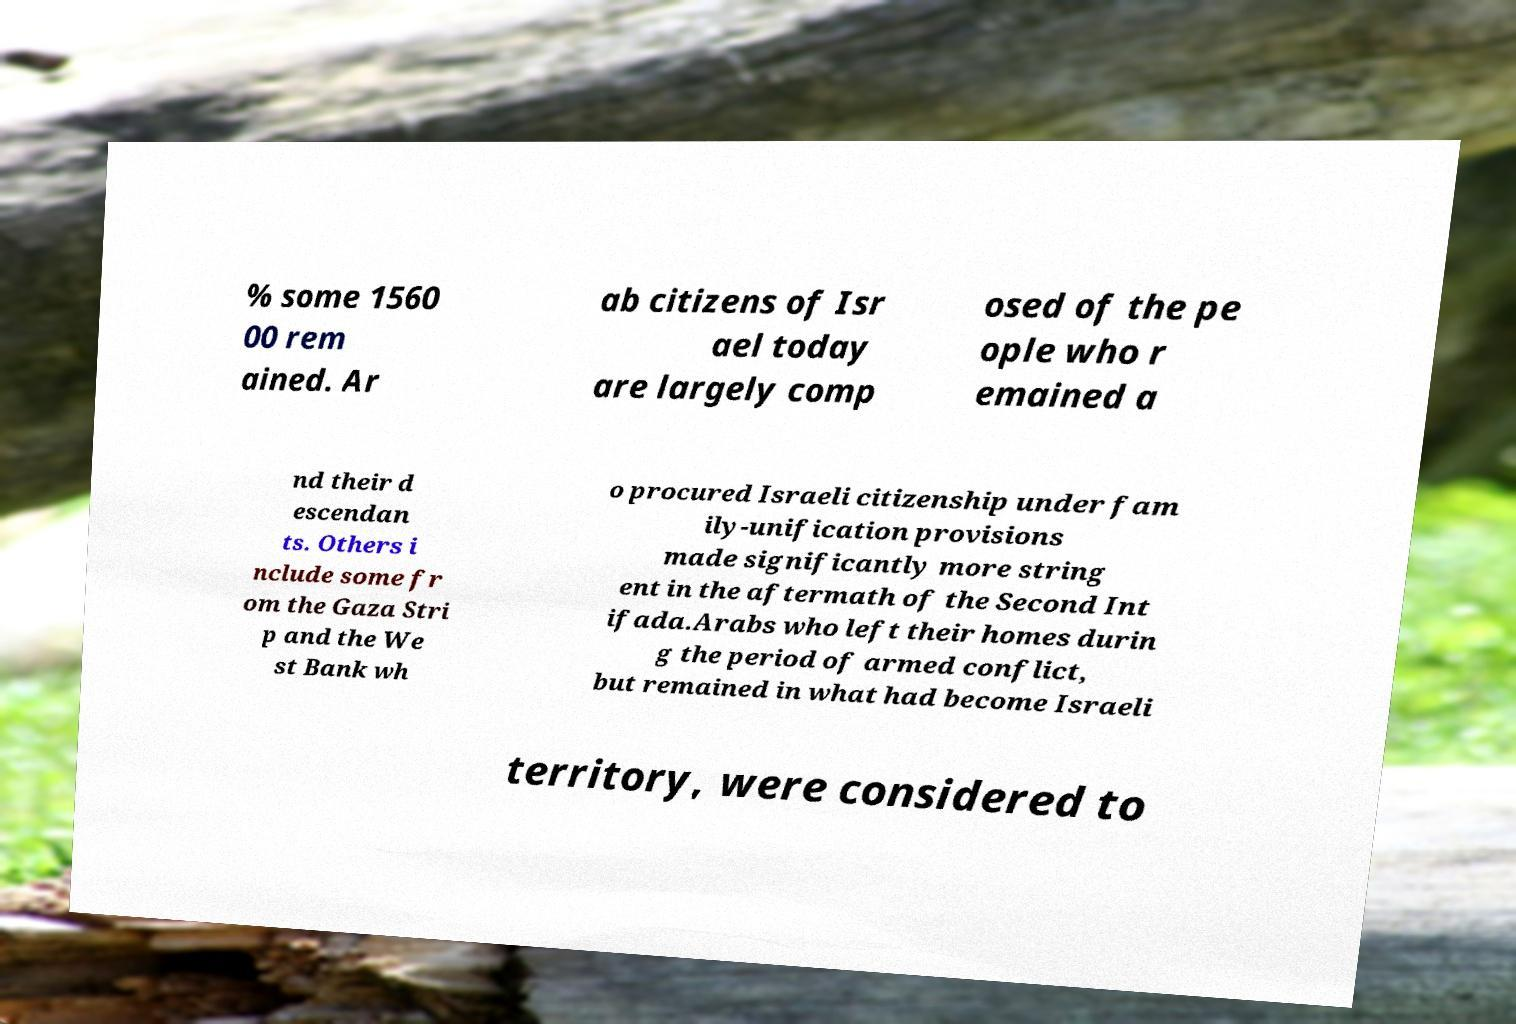Can you accurately transcribe the text from the provided image for me? % some 1560 00 rem ained. Ar ab citizens of Isr ael today are largely comp osed of the pe ople who r emained a nd their d escendan ts. Others i nclude some fr om the Gaza Stri p and the We st Bank wh o procured Israeli citizenship under fam ily-unification provisions made significantly more string ent in the aftermath of the Second Int ifada.Arabs who left their homes durin g the period of armed conflict, but remained in what had become Israeli territory, were considered to 